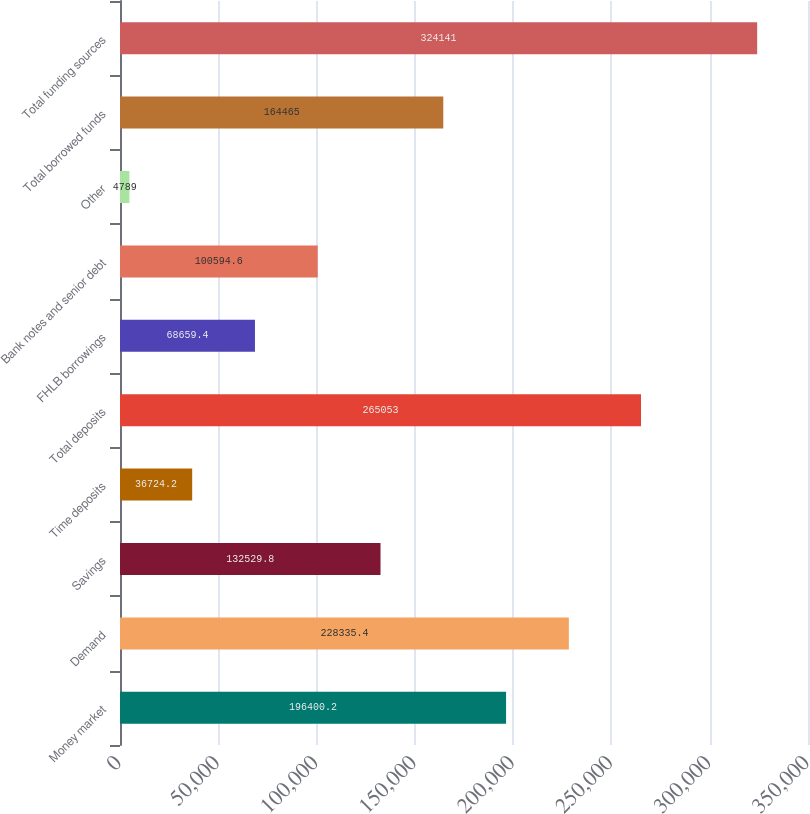<chart> <loc_0><loc_0><loc_500><loc_500><bar_chart><fcel>Money market<fcel>Demand<fcel>Savings<fcel>Time deposits<fcel>Total deposits<fcel>FHLB borrowings<fcel>Bank notes and senior debt<fcel>Other<fcel>Total borrowed funds<fcel>Total funding sources<nl><fcel>196400<fcel>228335<fcel>132530<fcel>36724.2<fcel>265053<fcel>68659.4<fcel>100595<fcel>4789<fcel>164465<fcel>324141<nl></chart> 